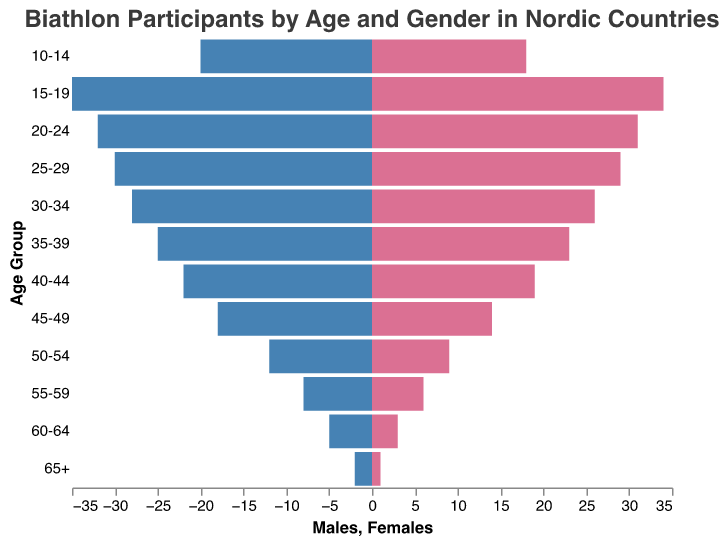Which age group has the most biathlon participants? By looking at the length of the bars, both males and females peak in the 15-19 age group. For males, this group has the highest count with 35 participants, and for females, it also has the highest count with 34 participants.
Answer: 15-19 How many more male participants are there in the 30-34 age group compared to females? From the data, the 30-34 age group has 28 males and 26 females. The difference is 28 - 26.
Answer: 2 What is the total number of participants in the 20-24 age group? Summing the number of males and females in the 20-24 age group: 32 males + 31 females.
Answer: 63 Which gender has more participants in the 40-44 age group? By observing the lengths of the bars for this age group, males have 22 participants while females have 19. Males have more participants.
Answer: Males What is the combined number of participants in both the 55-59 and 60-64 age groups? Summing the participants from both genders in both age groups: (8+6) + (5+3) = 14 + 8.
Answer: 22 Which age group has the smallest difference in the number of male and female participants? Examining the differences across the age groups, the 25-29 age group has the smallest difference: 30 males - 29 females = 1.
Answer: 25-29 How many total male participants are there in all age groups? Adding up all the male participants across age groups: 2+5+8+12+18+22+25+28+30+32+35+20.
Answer: 237 Is the number of female participants in the 10-14 age group greater than the number of male participants in the 65+ age group? The 10-14 age group has 18 females, and the 65+ age group has 2 males. 18 is greater than 2.
Answer: Yes In which age group do females constitute more than 50% of the participants? Checking each age group's male and female counts: In none of the age groups do females outnumber males.
Answer: None What is the average number of male participants across all age groups? Total male participants are 237 and the number of age groups is 12. Average = 237 / 12.
Answer: 19.75 